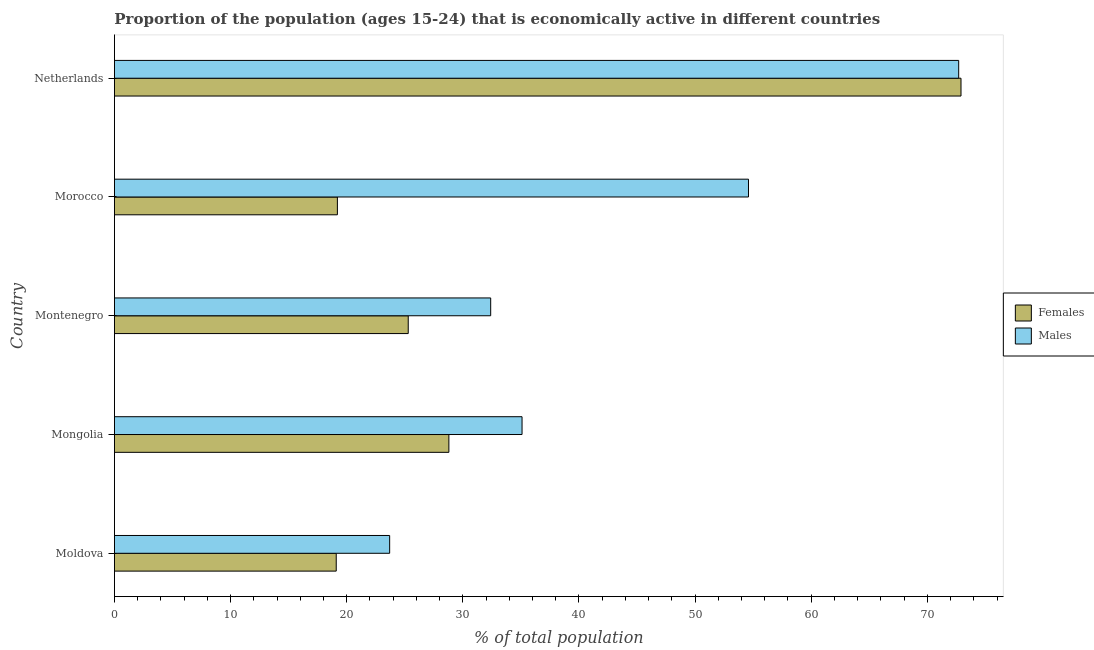How many different coloured bars are there?
Offer a terse response. 2. Are the number of bars per tick equal to the number of legend labels?
Your response must be concise. Yes. How many bars are there on the 3rd tick from the top?
Your response must be concise. 2. What is the label of the 2nd group of bars from the top?
Your answer should be very brief. Morocco. In how many cases, is the number of bars for a given country not equal to the number of legend labels?
Your response must be concise. 0. What is the percentage of economically active female population in Netherlands?
Ensure brevity in your answer.  72.9. Across all countries, what is the maximum percentage of economically active female population?
Keep it short and to the point. 72.9. Across all countries, what is the minimum percentage of economically active female population?
Provide a short and direct response. 19.1. In which country was the percentage of economically active female population maximum?
Provide a succinct answer. Netherlands. In which country was the percentage of economically active female population minimum?
Ensure brevity in your answer.  Moldova. What is the total percentage of economically active male population in the graph?
Give a very brief answer. 218.5. What is the difference between the percentage of economically active female population in Moldova and that in Morocco?
Your response must be concise. -0.1. What is the difference between the percentage of economically active female population in Netherlands and the percentage of economically active male population in Morocco?
Make the answer very short. 18.3. What is the average percentage of economically active female population per country?
Your answer should be very brief. 33.06. What is the difference between the percentage of economically active male population and percentage of economically active female population in Moldova?
Provide a succinct answer. 4.6. What is the ratio of the percentage of economically active female population in Morocco to that in Netherlands?
Ensure brevity in your answer.  0.26. What is the difference between the highest and the second highest percentage of economically active female population?
Your response must be concise. 44.1. In how many countries, is the percentage of economically active female population greater than the average percentage of economically active female population taken over all countries?
Ensure brevity in your answer.  1. Is the sum of the percentage of economically active female population in Moldova and Montenegro greater than the maximum percentage of economically active male population across all countries?
Offer a very short reply. No. What does the 2nd bar from the top in Montenegro represents?
Give a very brief answer. Females. What does the 2nd bar from the bottom in Morocco represents?
Give a very brief answer. Males. How many bars are there?
Keep it short and to the point. 10. How many countries are there in the graph?
Ensure brevity in your answer.  5. Are the values on the major ticks of X-axis written in scientific E-notation?
Provide a short and direct response. No. Does the graph contain any zero values?
Your response must be concise. No. How are the legend labels stacked?
Offer a very short reply. Vertical. What is the title of the graph?
Give a very brief answer. Proportion of the population (ages 15-24) that is economically active in different countries. What is the label or title of the X-axis?
Give a very brief answer. % of total population. What is the label or title of the Y-axis?
Provide a short and direct response. Country. What is the % of total population in Females in Moldova?
Make the answer very short. 19.1. What is the % of total population in Males in Moldova?
Make the answer very short. 23.7. What is the % of total population in Females in Mongolia?
Provide a succinct answer. 28.8. What is the % of total population of Males in Mongolia?
Make the answer very short. 35.1. What is the % of total population in Females in Montenegro?
Give a very brief answer. 25.3. What is the % of total population of Males in Montenegro?
Provide a succinct answer. 32.4. What is the % of total population of Females in Morocco?
Your answer should be compact. 19.2. What is the % of total population in Males in Morocco?
Ensure brevity in your answer.  54.6. What is the % of total population in Females in Netherlands?
Your response must be concise. 72.9. What is the % of total population of Males in Netherlands?
Your answer should be very brief. 72.7. Across all countries, what is the maximum % of total population in Females?
Keep it short and to the point. 72.9. Across all countries, what is the maximum % of total population of Males?
Ensure brevity in your answer.  72.7. Across all countries, what is the minimum % of total population of Females?
Your response must be concise. 19.1. Across all countries, what is the minimum % of total population of Males?
Make the answer very short. 23.7. What is the total % of total population in Females in the graph?
Your answer should be very brief. 165.3. What is the total % of total population of Males in the graph?
Keep it short and to the point. 218.5. What is the difference between the % of total population in Females in Moldova and that in Montenegro?
Keep it short and to the point. -6.2. What is the difference between the % of total population of Males in Moldova and that in Montenegro?
Make the answer very short. -8.7. What is the difference between the % of total population in Males in Moldova and that in Morocco?
Make the answer very short. -30.9. What is the difference between the % of total population in Females in Moldova and that in Netherlands?
Provide a short and direct response. -53.8. What is the difference between the % of total population in Males in Moldova and that in Netherlands?
Offer a terse response. -49. What is the difference between the % of total population in Females in Mongolia and that in Montenegro?
Your answer should be compact. 3.5. What is the difference between the % of total population in Males in Mongolia and that in Montenegro?
Offer a terse response. 2.7. What is the difference between the % of total population of Males in Mongolia and that in Morocco?
Give a very brief answer. -19.5. What is the difference between the % of total population of Females in Mongolia and that in Netherlands?
Ensure brevity in your answer.  -44.1. What is the difference between the % of total population in Males in Mongolia and that in Netherlands?
Your response must be concise. -37.6. What is the difference between the % of total population of Females in Montenegro and that in Morocco?
Make the answer very short. 6.1. What is the difference between the % of total population of Males in Montenegro and that in Morocco?
Your answer should be compact. -22.2. What is the difference between the % of total population in Females in Montenegro and that in Netherlands?
Offer a terse response. -47.6. What is the difference between the % of total population in Males in Montenegro and that in Netherlands?
Your response must be concise. -40.3. What is the difference between the % of total population of Females in Morocco and that in Netherlands?
Provide a succinct answer. -53.7. What is the difference between the % of total population of Males in Morocco and that in Netherlands?
Your response must be concise. -18.1. What is the difference between the % of total population in Females in Moldova and the % of total population in Males in Montenegro?
Ensure brevity in your answer.  -13.3. What is the difference between the % of total population of Females in Moldova and the % of total population of Males in Morocco?
Ensure brevity in your answer.  -35.5. What is the difference between the % of total population of Females in Moldova and the % of total population of Males in Netherlands?
Your answer should be compact. -53.6. What is the difference between the % of total population of Females in Mongolia and the % of total population of Males in Montenegro?
Keep it short and to the point. -3.6. What is the difference between the % of total population of Females in Mongolia and the % of total population of Males in Morocco?
Your answer should be compact. -25.8. What is the difference between the % of total population in Females in Mongolia and the % of total population in Males in Netherlands?
Ensure brevity in your answer.  -43.9. What is the difference between the % of total population of Females in Montenegro and the % of total population of Males in Morocco?
Your response must be concise. -29.3. What is the difference between the % of total population of Females in Montenegro and the % of total population of Males in Netherlands?
Offer a very short reply. -47.4. What is the difference between the % of total population of Females in Morocco and the % of total population of Males in Netherlands?
Offer a very short reply. -53.5. What is the average % of total population in Females per country?
Ensure brevity in your answer.  33.06. What is the average % of total population of Males per country?
Your response must be concise. 43.7. What is the difference between the % of total population of Females and % of total population of Males in Morocco?
Provide a succinct answer. -35.4. What is the difference between the % of total population in Females and % of total population in Males in Netherlands?
Provide a short and direct response. 0.2. What is the ratio of the % of total population in Females in Moldova to that in Mongolia?
Your answer should be compact. 0.66. What is the ratio of the % of total population in Males in Moldova to that in Mongolia?
Offer a terse response. 0.68. What is the ratio of the % of total population in Females in Moldova to that in Montenegro?
Keep it short and to the point. 0.75. What is the ratio of the % of total population in Males in Moldova to that in Montenegro?
Offer a terse response. 0.73. What is the ratio of the % of total population of Females in Moldova to that in Morocco?
Keep it short and to the point. 0.99. What is the ratio of the % of total population of Males in Moldova to that in Morocco?
Ensure brevity in your answer.  0.43. What is the ratio of the % of total population of Females in Moldova to that in Netherlands?
Your response must be concise. 0.26. What is the ratio of the % of total population in Males in Moldova to that in Netherlands?
Provide a succinct answer. 0.33. What is the ratio of the % of total population in Females in Mongolia to that in Montenegro?
Offer a very short reply. 1.14. What is the ratio of the % of total population in Males in Mongolia to that in Morocco?
Keep it short and to the point. 0.64. What is the ratio of the % of total population of Females in Mongolia to that in Netherlands?
Provide a succinct answer. 0.4. What is the ratio of the % of total population in Males in Mongolia to that in Netherlands?
Keep it short and to the point. 0.48. What is the ratio of the % of total population in Females in Montenegro to that in Morocco?
Make the answer very short. 1.32. What is the ratio of the % of total population in Males in Montenegro to that in Morocco?
Provide a short and direct response. 0.59. What is the ratio of the % of total population of Females in Montenegro to that in Netherlands?
Keep it short and to the point. 0.35. What is the ratio of the % of total population in Males in Montenegro to that in Netherlands?
Your answer should be very brief. 0.45. What is the ratio of the % of total population in Females in Morocco to that in Netherlands?
Give a very brief answer. 0.26. What is the ratio of the % of total population of Males in Morocco to that in Netherlands?
Provide a succinct answer. 0.75. What is the difference between the highest and the second highest % of total population of Females?
Make the answer very short. 44.1. What is the difference between the highest and the lowest % of total population in Females?
Give a very brief answer. 53.8. 